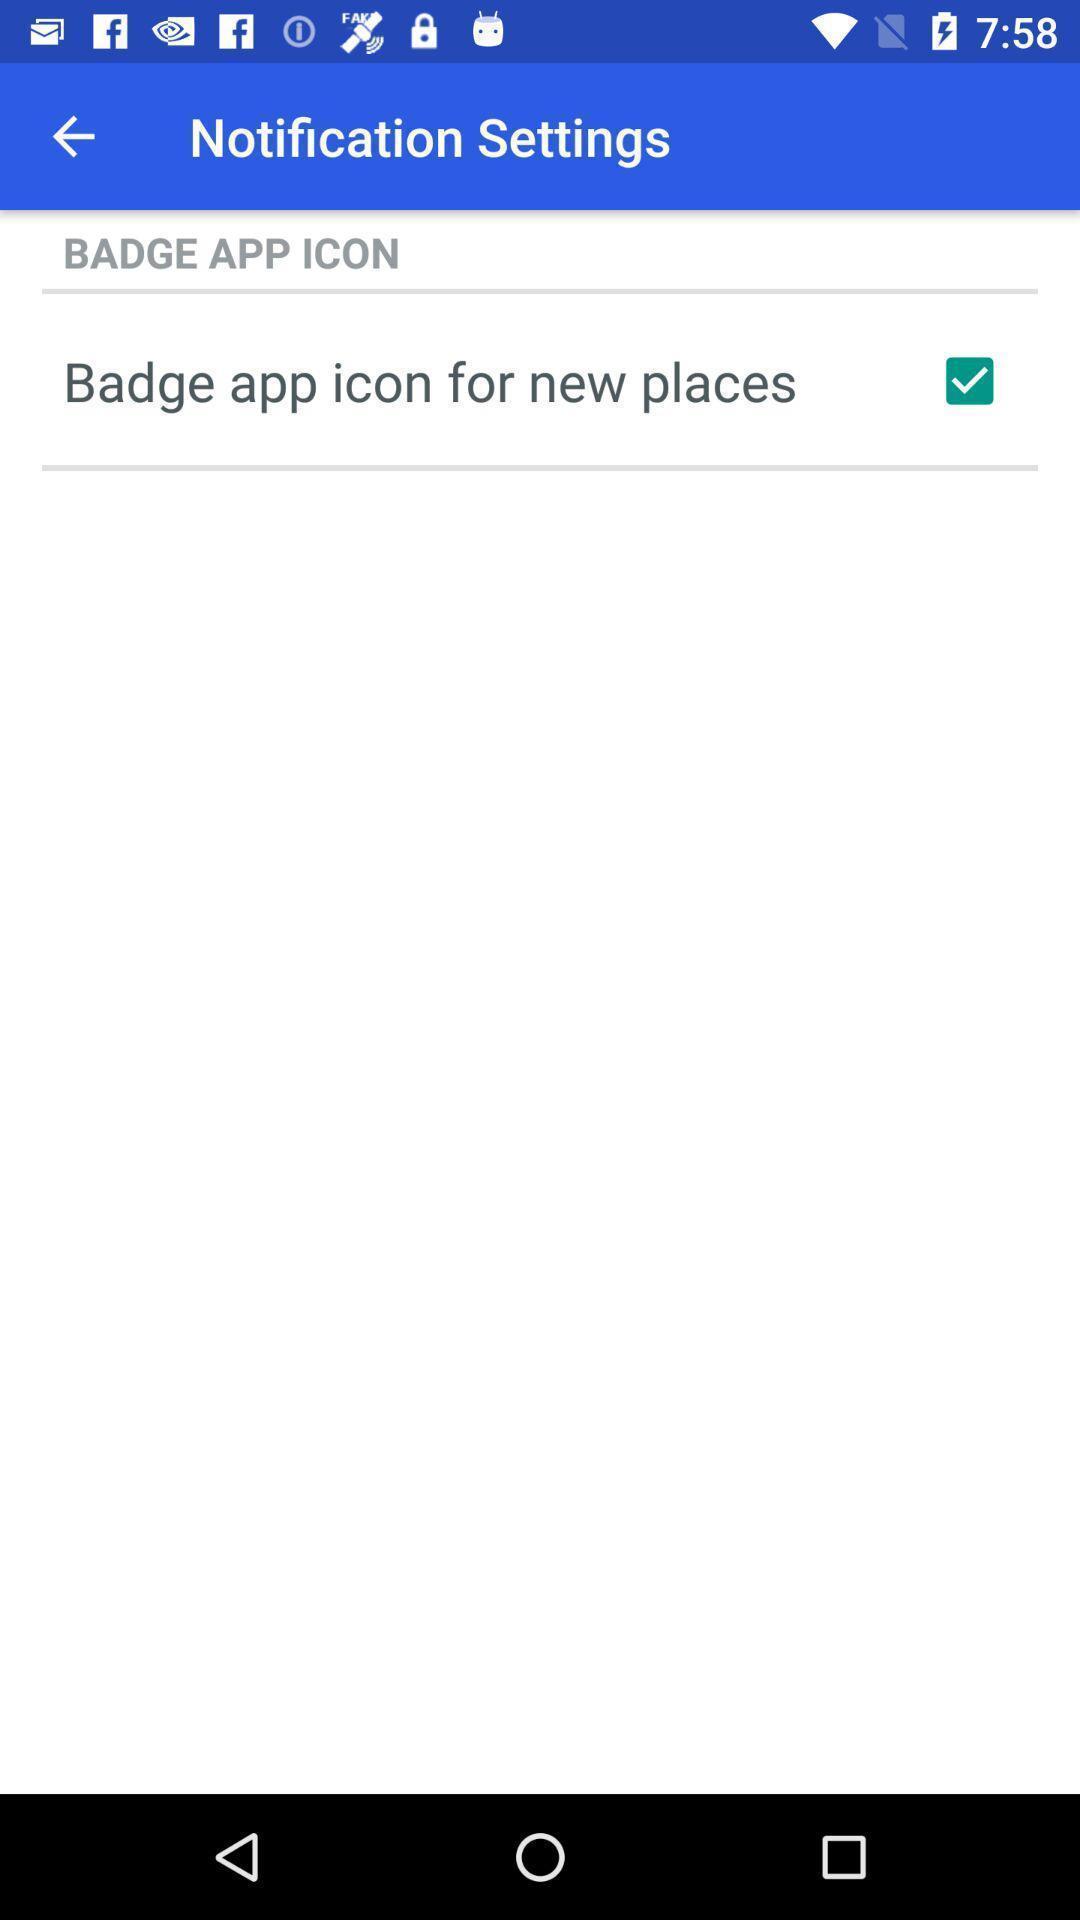Give me a summary of this screen capture. Screen displaying settings for the notifications. 